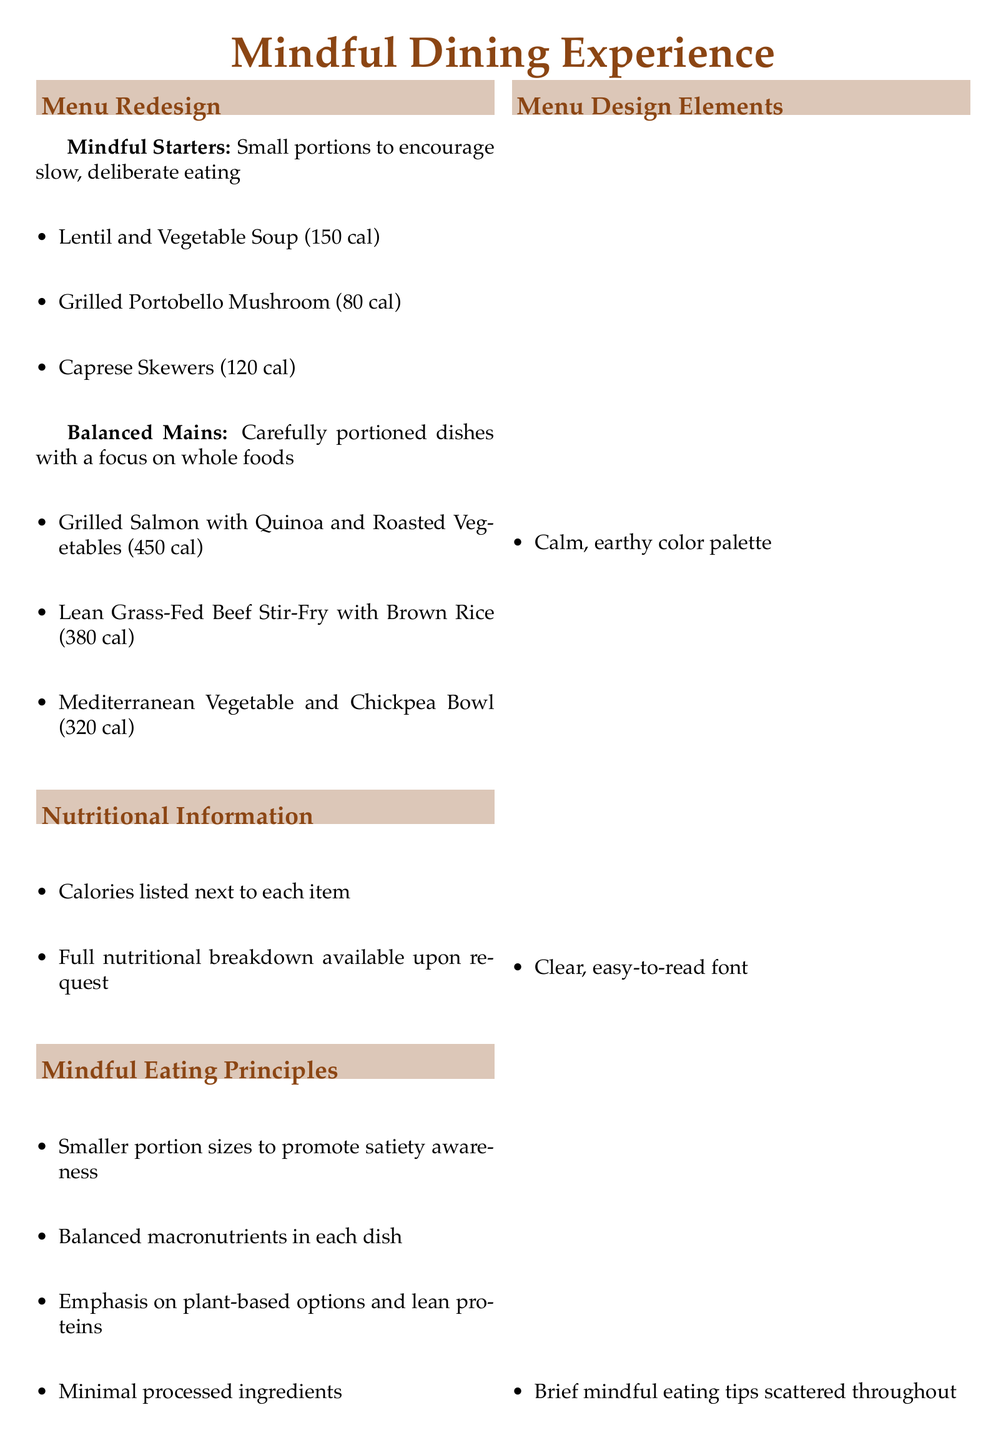What are the three categories of menu items? The menu features two categories of items: "Mindful Starters" and "Balanced Mains".
Answer: Mindful Starters, Balanced Mains What is the calorie count of the Grilled Portobello Mushroom? The calorie count for the Grilled Portobello Mushroom is listed next to the item in the menu.
Answer: 80 cal Name one principle of mindful eating mentioned in the document. The document lists several principles of mindful eating, one of which is smaller portion sizes to promote satiety awareness.
Answer: Smaller portion sizes What colors are used in the menu design? The document specifies a calm, earthy color palette, particularly mentioning earth brown and leaf green.
Answer: Earth brown, leaf green How many items are in the Balanced Mains section? The number of items in the Balanced Mains section is provided in the menu description.
Answer: Three What feature is included for customization of meals? The document mentions a special section that allows patrons to customize meals according to their nutritional needs.
Answer: 'Build Your Own' section What information is displayed next to each menu item? The document states that calories are displayed next to each menu item in the menu.
Answer: Calories What is the suggested way to appreciate food before eating? The document provides a mindful eating tip regarding the appreciation of food before consumption.
Answer: Appreciate the colors, textures, and aromas 